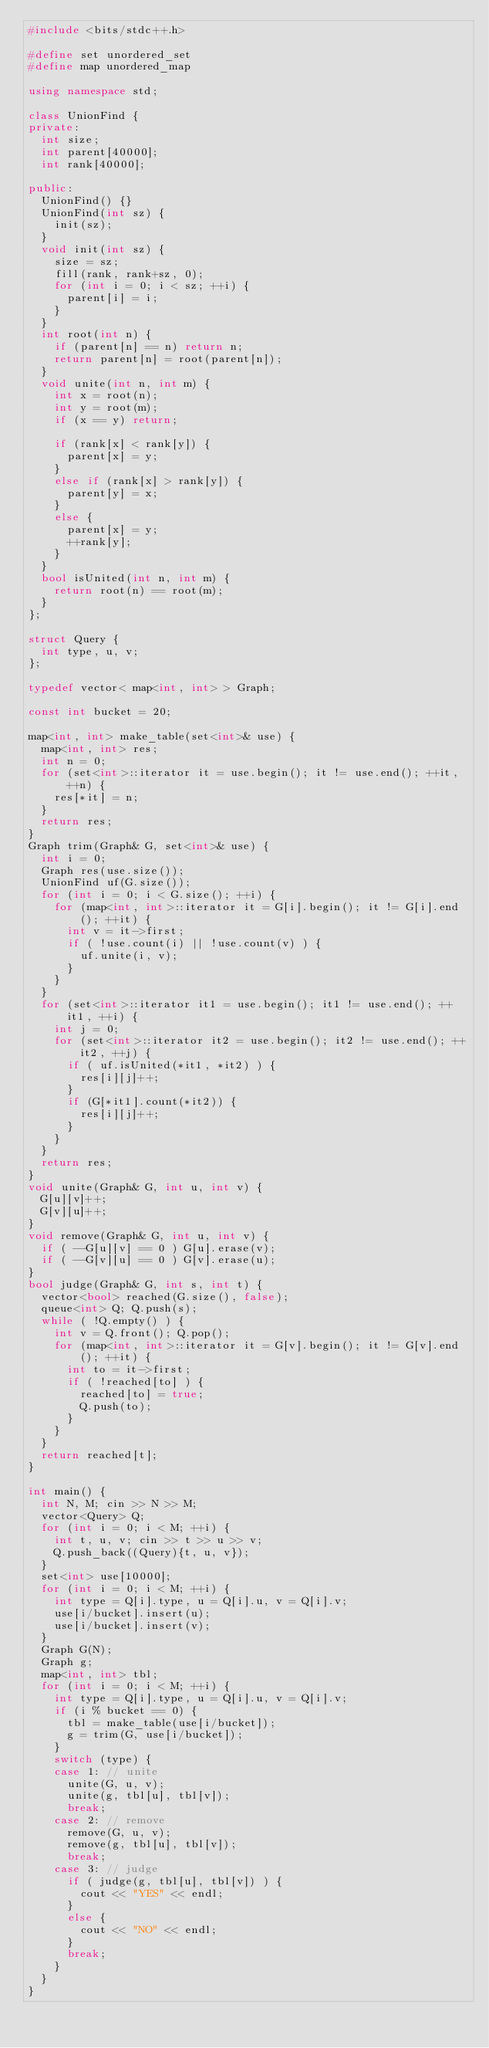Convert code to text. <code><loc_0><loc_0><loc_500><loc_500><_C++_>#include <bits/stdc++.h>

#define set unordered_set
#define map unordered_map

using namespace std;

class UnionFind {
private:
	int size;
	int parent[40000];
	int rank[40000];

public:
	UnionFind() {}
	UnionFind(int sz) {
		init(sz);
	}
	void init(int sz) {
		size = sz;
		fill(rank, rank+sz, 0);
		for (int i = 0; i < sz; ++i) {
			parent[i] = i;
		}
	}
	int root(int n) {
		if (parent[n] == n) return n;
		return parent[n] = root(parent[n]);
	}
	void unite(int n, int m) {
		int x = root(n);
		int y = root(m);
		if (x == y) return;

		if (rank[x] < rank[y]) {
			parent[x] = y;
		}
		else if (rank[x] > rank[y]) {
			parent[y] = x;
		}
		else {
			parent[x] = y;
			++rank[y];
		}
	}
	bool isUnited(int n, int m) {
		return root(n) == root(m);
	}
};

struct Query {
	int type, u, v;
};

typedef vector< map<int, int> > Graph;

const int bucket = 20;

map<int, int> make_table(set<int>& use) {
	map<int, int> res;
	int n = 0;
	for (set<int>::iterator it = use.begin(); it != use.end(); ++it, ++n) {
		res[*it] = n;
	}
	return res;
}
Graph trim(Graph& G, set<int>& use) {
	int i = 0;
	Graph res(use.size());
	UnionFind uf(G.size());
	for (int i = 0; i < G.size(); ++i) {
		for (map<int, int>::iterator it = G[i].begin(); it != G[i].end(); ++it) {
			int v = it->first;
			if ( !use.count(i) || !use.count(v) ) {
				uf.unite(i, v);
			}
		}
	}
	for (set<int>::iterator it1 = use.begin(); it1 != use.end(); ++it1, ++i) {
		int j = 0;
		for (set<int>::iterator it2 = use.begin(); it2 != use.end(); ++it2, ++j) {
			if ( uf.isUnited(*it1, *it2) ) {
				res[i][j]++;
			}
			if (G[*it1].count(*it2)) {
				res[i][j]++;
			}
		}
	}
	return res;
}
void unite(Graph& G, int u, int v) {
	G[u][v]++;
	G[v][u]++;
}
void remove(Graph& G, int u, int v) {
	if ( --G[u][v] == 0 ) G[u].erase(v);
	if ( --G[v][u] == 0 ) G[v].erase(u);
}
bool judge(Graph& G, int s, int t) {
	vector<bool> reached(G.size(), false);
	queue<int> Q; Q.push(s);
	while ( !Q.empty() ) {
		int v = Q.front(); Q.pop();
		for (map<int, int>::iterator it = G[v].begin(); it != G[v].end(); ++it) {
			int to = it->first;
			if ( !reached[to] ) {
				reached[to] = true;
				Q.push(to);
			}
		}
	}
	return reached[t];
}

int main() {
	int N, M; cin >> N >> M;
	vector<Query> Q;
	for (int i = 0; i < M; ++i) {
		int t, u, v; cin >> t >> u >> v;
		Q.push_back((Query){t, u, v});
	}
	set<int> use[10000];
	for (int i = 0; i < M; ++i) {
		int type = Q[i].type, u = Q[i].u, v = Q[i].v;
		use[i/bucket].insert(u);
		use[i/bucket].insert(v);
	}
	Graph G(N);
	Graph g;
	map<int, int> tbl;
	for (int i = 0; i < M; ++i) {
		int type = Q[i].type, u = Q[i].u, v = Q[i].v;
		if (i % bucket == 0) {
			tbl = make_table(use[i/bucket]);
			g = trim(G, use[i/bucket]);
		}
		switch (type) {
		case 1: // unite
			unite(G, u, v);
			unite(g, tbl[u], tbl[v]);
			break;
		case 2: // remove
			remove(G, u, v);
			remove(g, tbl[u], tbl[v]);
			break;
		case 3: // judge
			if ( judge(g, tbl[u], tbl[v]) ) {
				cout << "YES" << endl;
			}
			else {
				cout << "NO" << endl;
			}
			break;
		}
	}
}</code> 